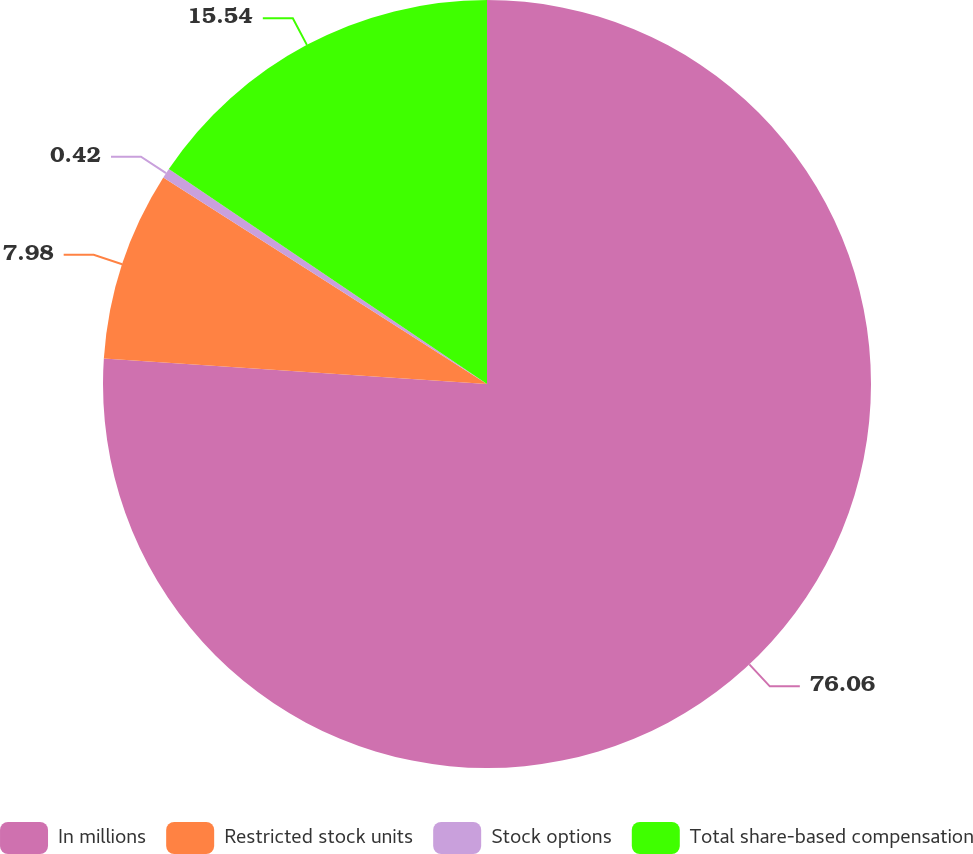Convert chart to OTSL. <chart><loc_0><loc_0><loc_500><loc_500><pie_chart><fcel>In millions<fcel>Restricted stock units<fcel>Stock options<fcel>Total share-based compensation<nl><fcel>76.06%<fcel>7.98%<fcel>0.42%<fcel>15.54%<nl></chart> 